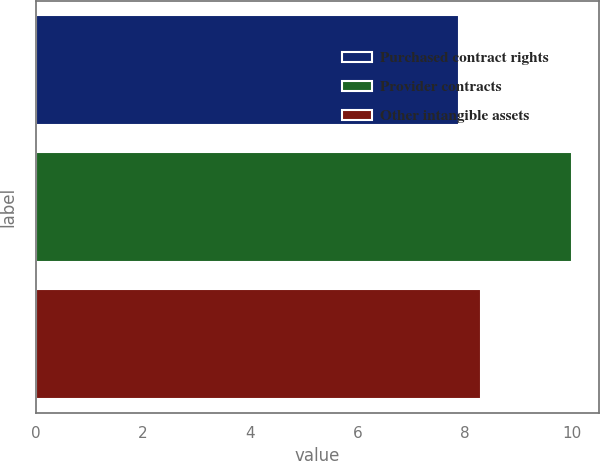Convert chart. <chart><loc_0><loc_0><loc_500><loc_500><bar_chart><fcel>Purchased contract rights<fcel>Provider contracts<fcel>Other intangible assets<nl><fcel>7.9<fcel>10<fcel>8.3<nl></chart> 